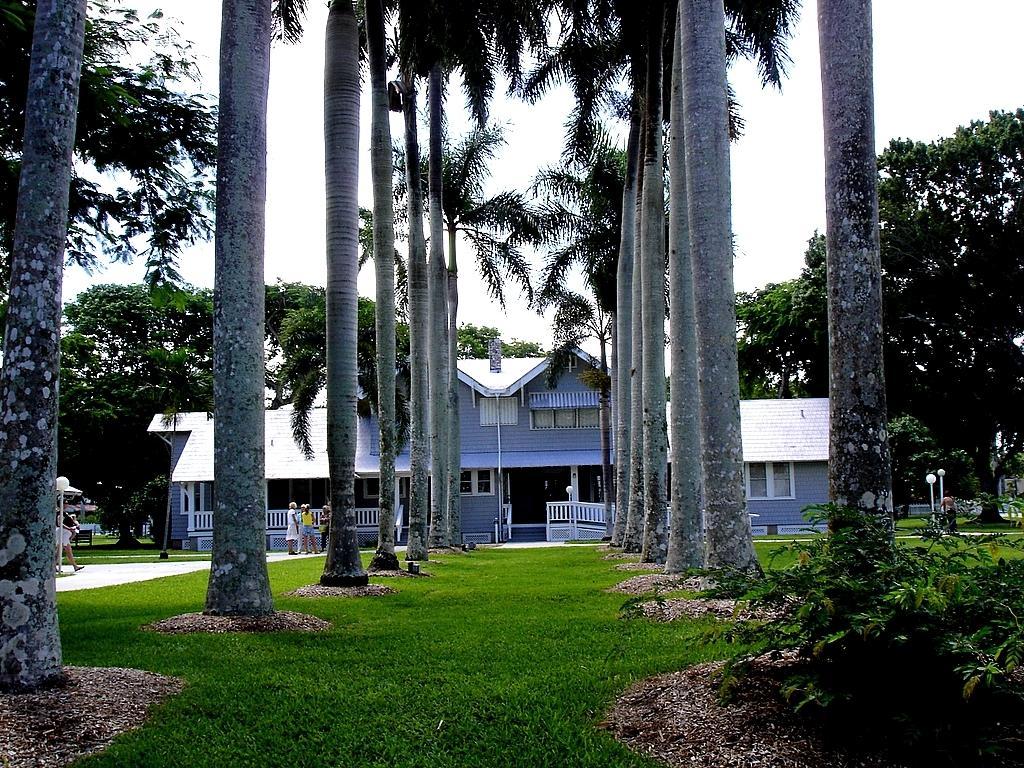Can you describe this image briefly? In this picture, we can see a few people, house, fencing, ground with grass, poles, plants, trees, lights, and the sky. 